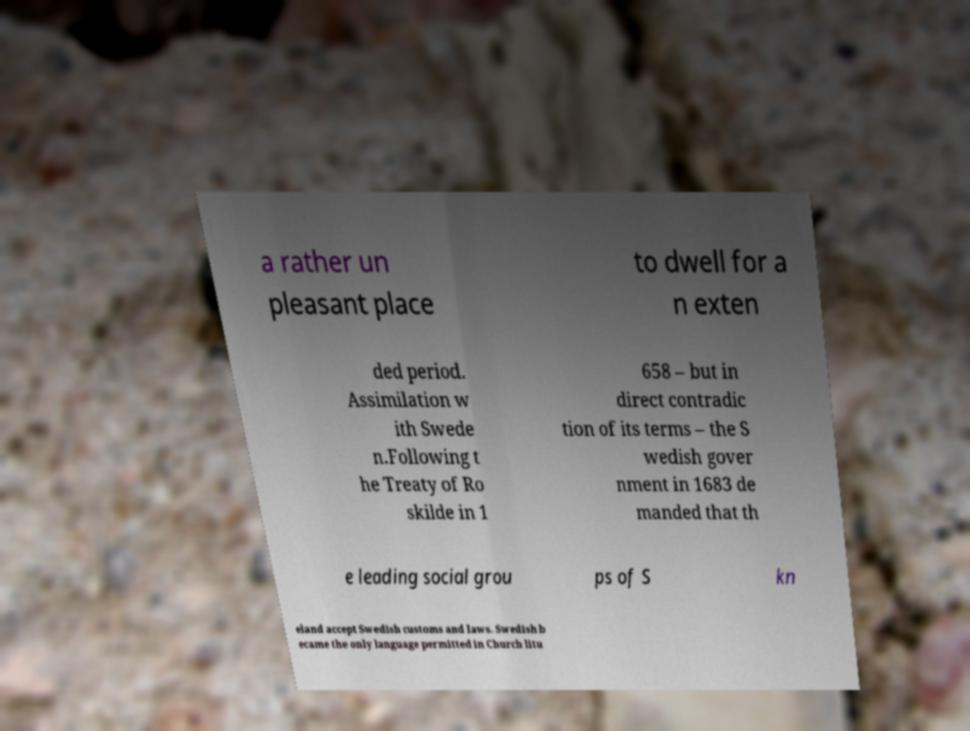I need the written content from this picture converted into text. Can you do that? a rather un pleasant place to dwell for a n exten ded period. Assimilation w ith Swede n.Following t he Treaty of Ro skilde in 1 658 – but in direct contradic tion of its terms – the S wedish gover nment in 1683 de manded that th e leading social grou ps of S kn eland accept Swedish customs and laws. Swedish b ecame the only language permitted in Church litu 